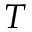<formula> <loc_0><loc_0><loc_500><loc_500>T</formula> 